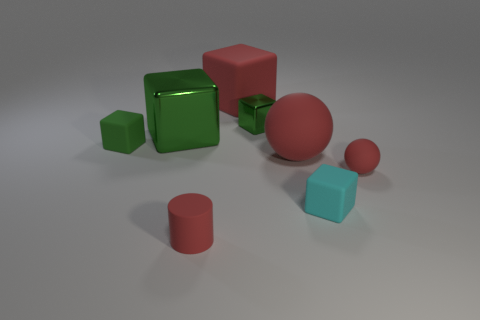Subtract all green blocks. How many were subtracted if there are1green blocks left? 2 Subtract all yellow cylinders. How many green blocks are left? 3 Subtract all cyan blocks. How many blocks are left? 4 Subtract all big cubes. How many cubes are left? 3 Subtract 2 blocks. How many blocks are left? 3 Add 1 big spheres. How many objects exist? 9 Subtract all gray cubes. Subtract all cyan cylinders. How many cubes are left? 5 Subtract all cylinders. How many objects are left? 7 Subtract all brown rubber spheres. Subtract all tiny cyan rubber things. How many objects are left? 7 Add 1 tiny matte spheres. How many tiny matte spheres are left? 2 